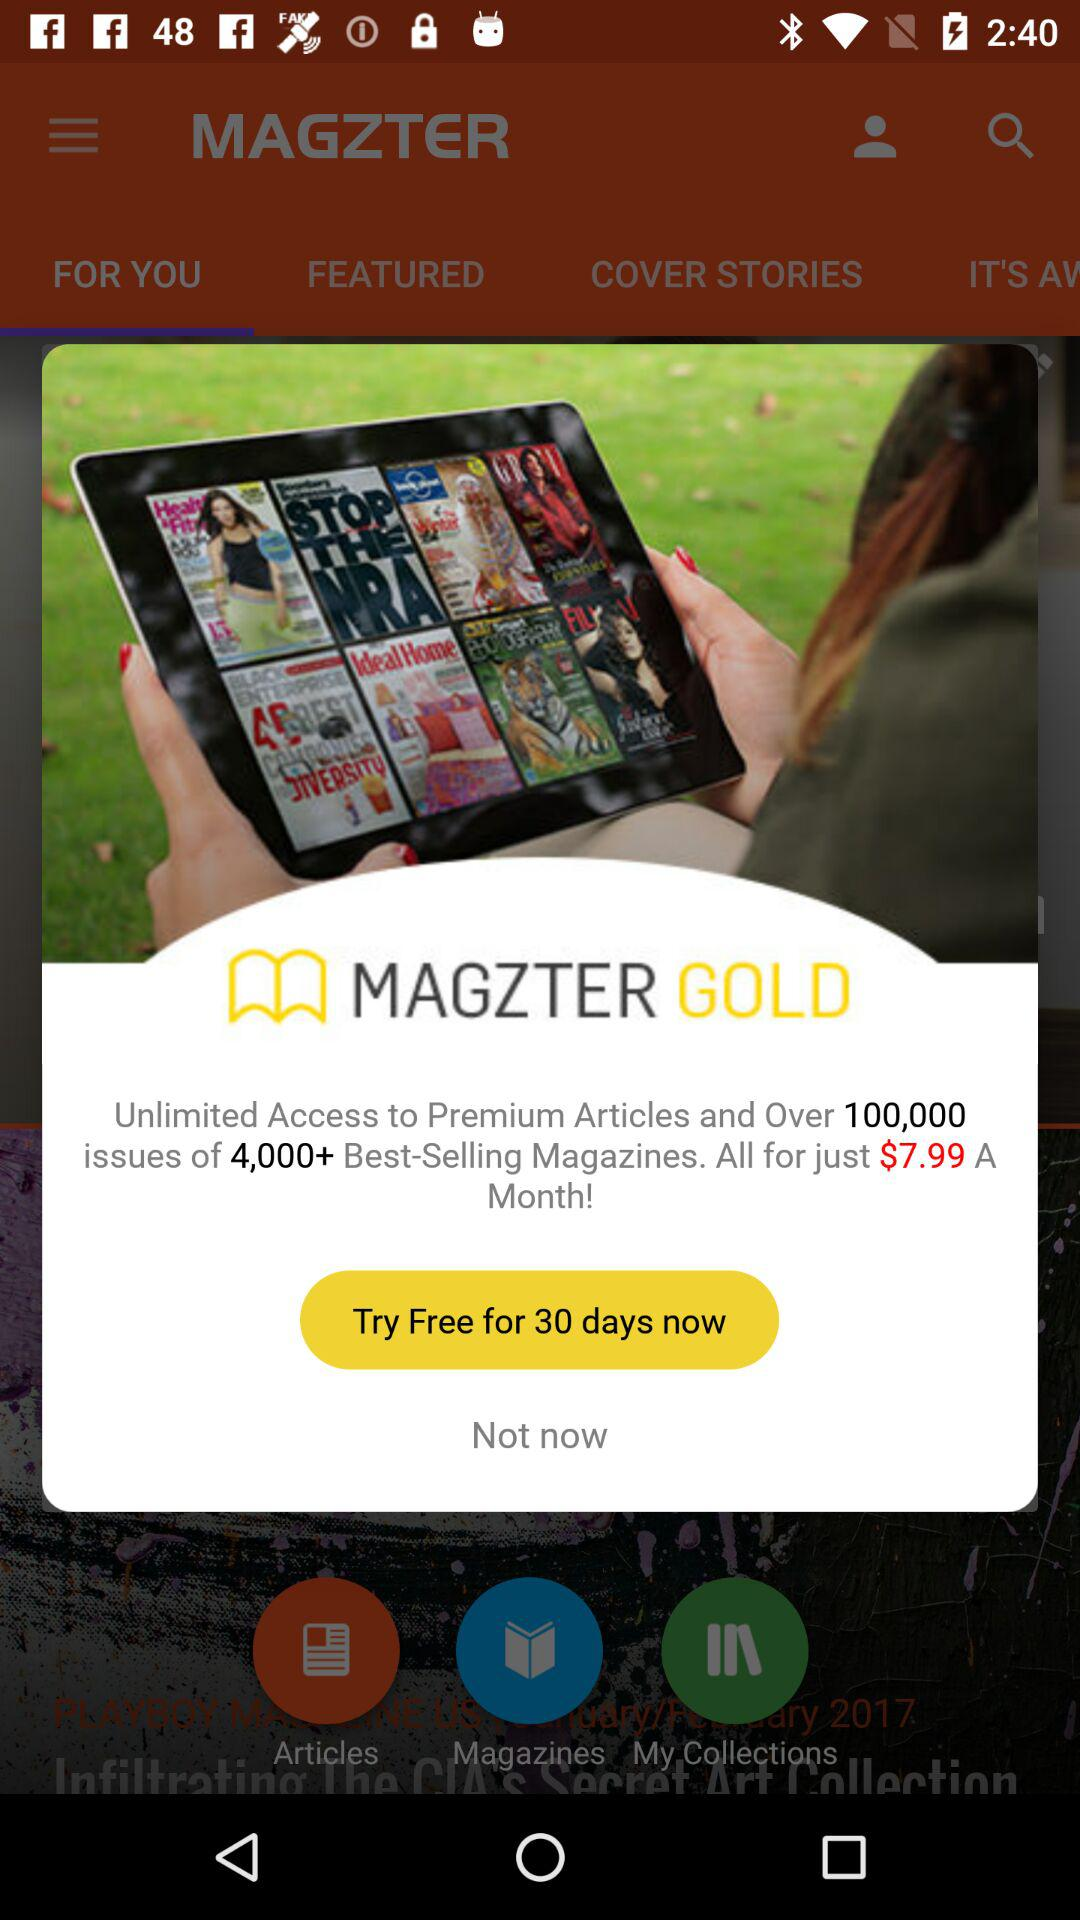How many best-selling magazines are there? There are 4000+ best-selling magazines. 